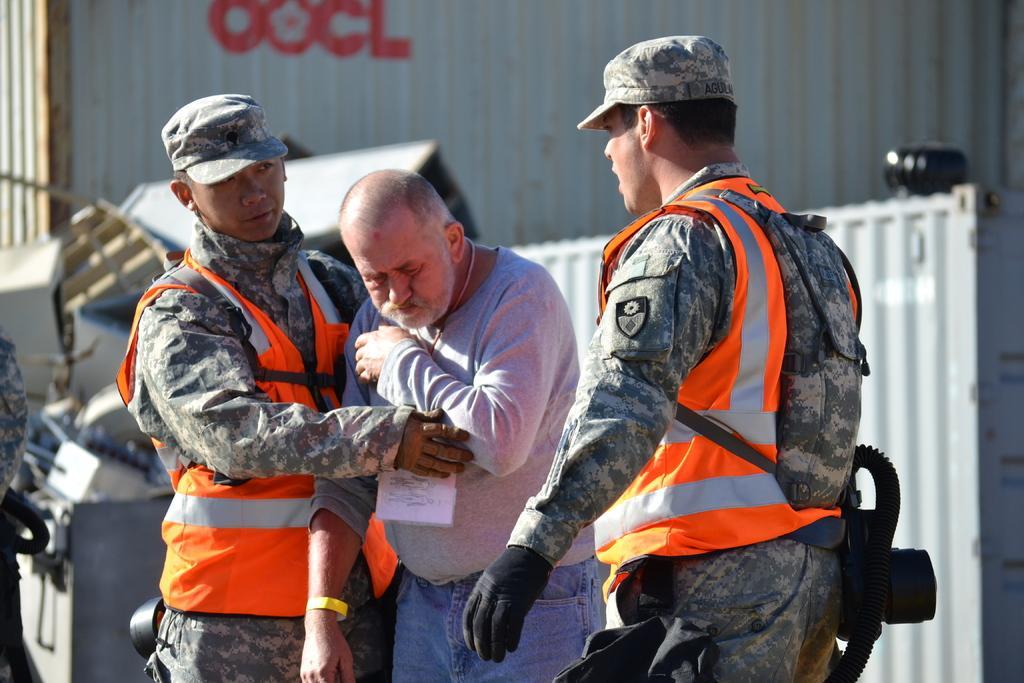Describe this image in one or two sentences. In the foreground of this image, there are three men standing where two men are wearing jackets. In the background, it seems like containers, few objects and a person on the left. 